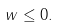Convert formula to latex. <formula><loc_0><loc_0><loc_500><loc_500>w \leq 0 .</formula> 